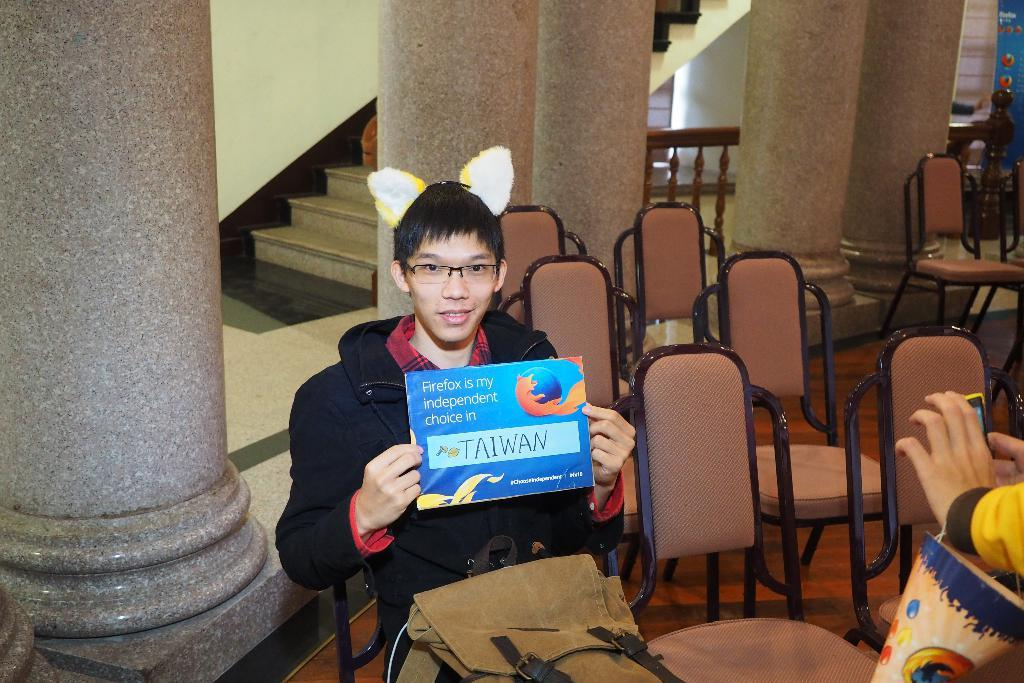What is the person in the image doing? The person is sitting on a chair in the image. What is the person holding in the image? The person is holding a poster in the image. What can be seen in the background of the image? There is a pillar, staircases, and a wall in the background of the image. What type of wax can be seen dripping from the iron in the image? There is no wax or iron present in the image. 